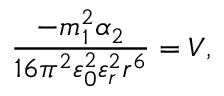<formula> <loc_0><loc_0><loc_500><loc_500>{ \frac { - m _ { 1 } ^ { 2 } \alpha _ { 2 } } { 1 6 \pi ^ { 2 } \varepsilon _ { 0 } ^ { 2 } \varepsilon _ { r } ^ { 2 } r ^ { 6 } } } = V ,</formula> 